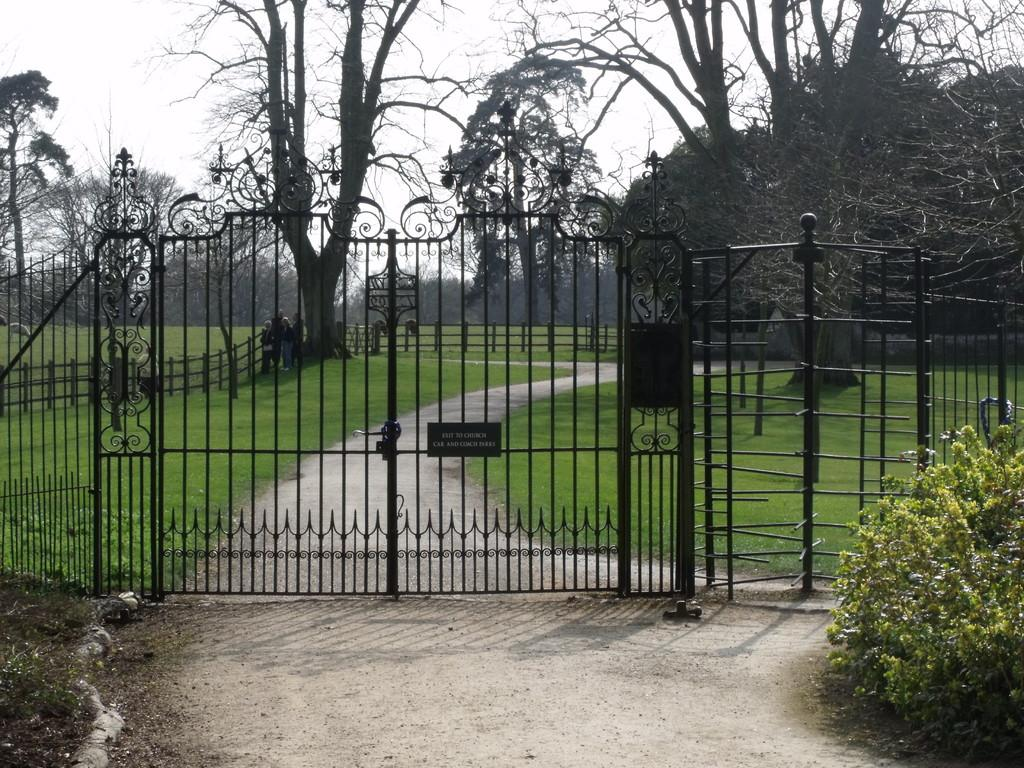What is the main structure in the center of the image? There is a gate in the center of the image. What type of vegetation is on the right side of the image? There is a bush on the right side of the image. What can be seen in the background of the image? There are trees, a fence, and the sky visible in the background of the image. What is the taste of the stream in the image? There is no stream present in the image, so it is not possible to determine its taste. 